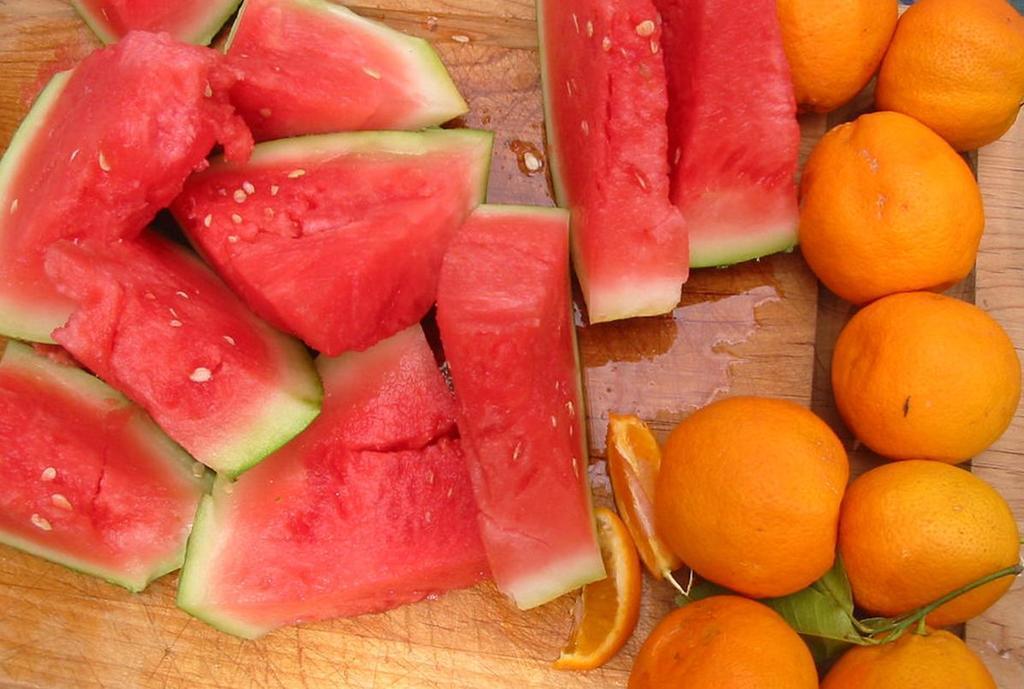Please provide a concise description of this image. In this picture we can observe two different types of fruits placed on the brown color table. We can observe watermelon and oranges. This watermelon was made into some pieces. 